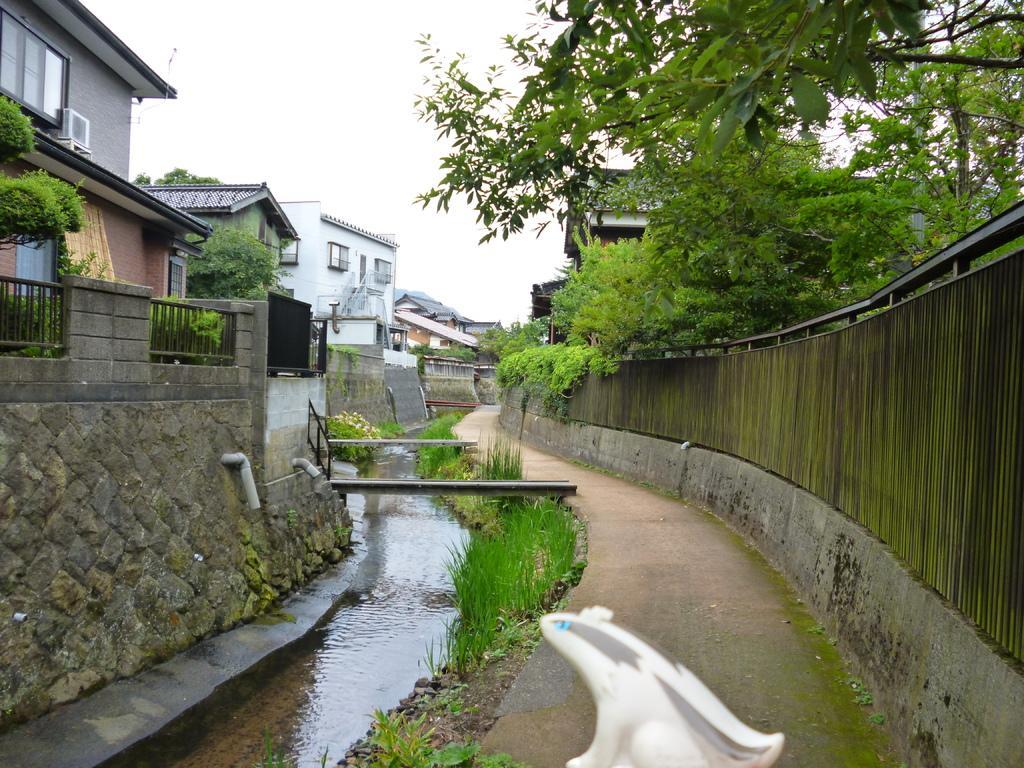How would you summarize this image in a sentence or two? In the foreground of the picture we can see canal, plants, grass, soil, path and other objects. On the left there are buildings, trees, railing, walls and plants. On the right we can see trees, buildings and wall. At the top there is sky. 